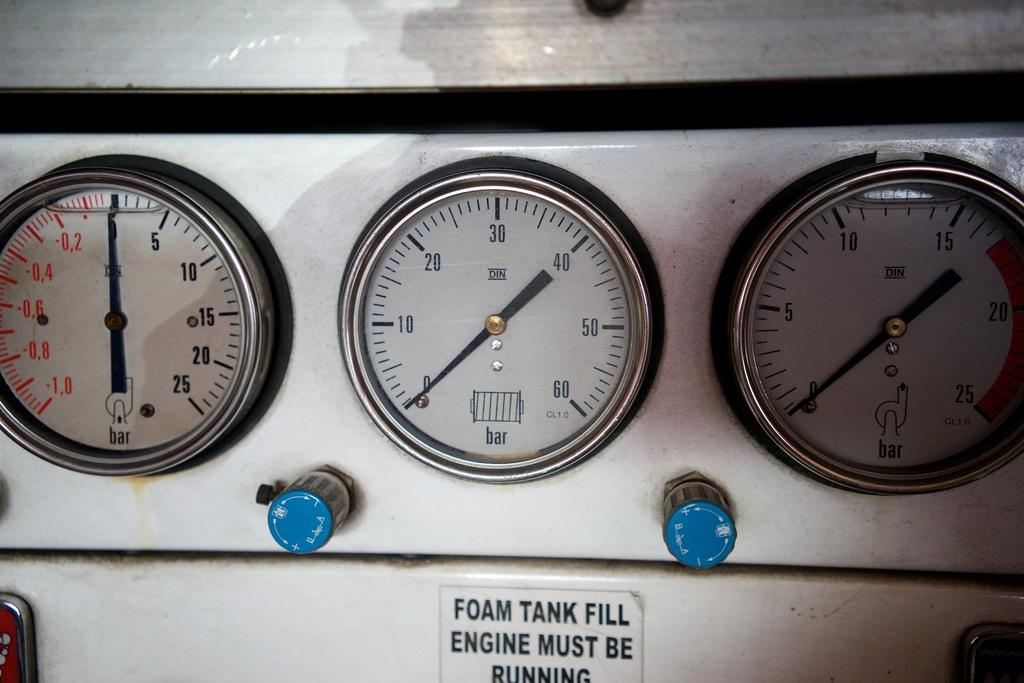What type of objects are present in the image? There are meters in the image. What color can be observed among the objects in the image? There are blue color objects in the image. Can you describe any text or symbols in the image? There is writing on a surface in the image. What type of floor can be seen in the image? There is no floor visible in the image; it only shows meters and blue objects with writing on a surface. 